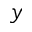Convert formula to latex. <formula><loc_0><loc_0><loc_500><loc_500>y</formula> 